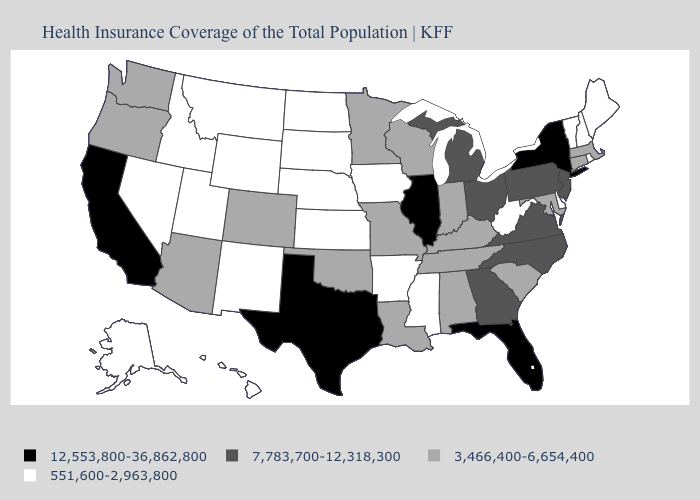What is the value of Louisiana?
Keep it brief. 3,466,400-6,654,400. Name the states that have a value in the range 551,600-2,963,800?
Write a very short answer. Alaska, Arkansas, Delaware, Hawaii, Idaho, Iowa, Kansas, Maine, Mississippi, Montana, Nebraska, Nevada, New Hampshire, New Mexico, North Dakota, Rhode Island, South Dakota, Utah, Vermont, West Virginia, Wyoming. Does New Mexico have the lowest value in the West?
Be succinct. Yes. Is the legend a continuous bar?
Be succinct. No. Among the states that border Maryland , does Delaware have the lowest value?
Concise answer only. Yes. What is the value of Louisiana?
Keep it brief. 3,466,400-6,654,400. Among the states that border Vermont , does New Hampshire have the lowest value?
Be succinct. Yes. Name the states that have a value in the range 551,600-2,963,800?
Short answer required. Alaska, Arkansas, Delaware, Hawaii, Idaho, Iowa, Kansas, Maine, Mississippi, Montana, Nebraska, Nevada, New Hampshire, New Mexico, North Dakota, Rhode Island, South Dakota, Utah, Vermont, West Virginia, Wyoming. Name the states that have a value in the range 7,783,700-12,318,300?
Give a very brief answer. Georgia, Michigan, New Jersey, North Carolina, Ohio, Pennsylvania, Virginia. Among the states that border New Jersey , does Delaware have the highest value?
Short answer required. No. What is the lowest value in states that border North Carolina?
Quick response, please. 3,466,400-6,654,400. Does the map have missing data?
Be succinct. No. What is the value of Minnesota?
Quick response, please. 3,466,400-6,654,400. What is the lowest value in the USA?
Quick response, please. 551,600-2,963,800. What is the lowest value in states that border Indiana?
Give a very brief answer. 3,466,400-6,654,400. 